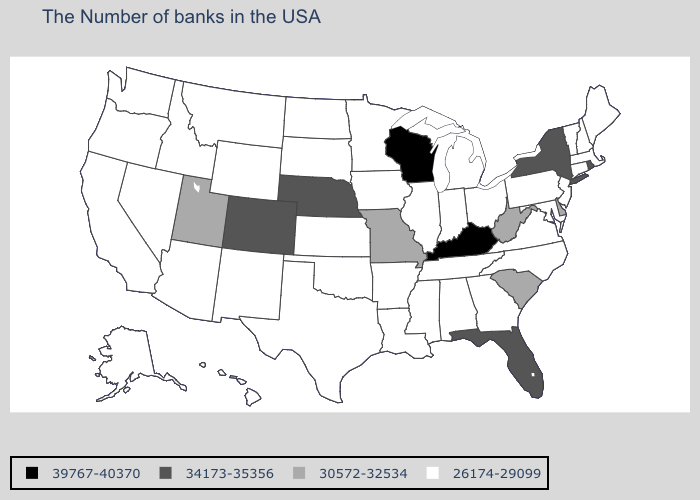Does Tennessee have the lowest value in the South?
Quick response, please. Yes. Does New Jersey have the same value as Michigan?
Concise answer only. Yes. Does Wisconsin have the highest value in the USA?
Be succinct. Yes. Name the states that have a value in the range 34173-35356?
Answer briefly. Rhode Island, New York, Florida, Nebraska, Colorado. What is the highest value in states that border Iowa?
Quick response, please. 39767-40370. What is the lowest value in the South?
Quick response, please. 26174-29099. Does Nebraska have a higher value than Kentucky?
Concise answer only. No. Does Texas have a lower value than Pennsylvania?
Keep it brief. No. Does Wyoming have a lower value than Arizona?
Concise answer only. No. Name the states that have a value in the range 34173-35356?
Keep it brief. Rhode Island, New York, Florida, Nebraska, Colorado. Name the states that have a value in the range 30572-32534?
Give a very brief answer. Delaware, South Carolina, West Virginia, Missouri, Utah. Which states hav the highest value in the West?
Keep it brief. Colorado. Among the states that border Iowa , which have the highest value?
Be succinct. Wisconsin. Name the states that have a value in the range 34173-35356?
Answer briefly. Rhode Island, New York, Florida, Nebraska, Colorado. 